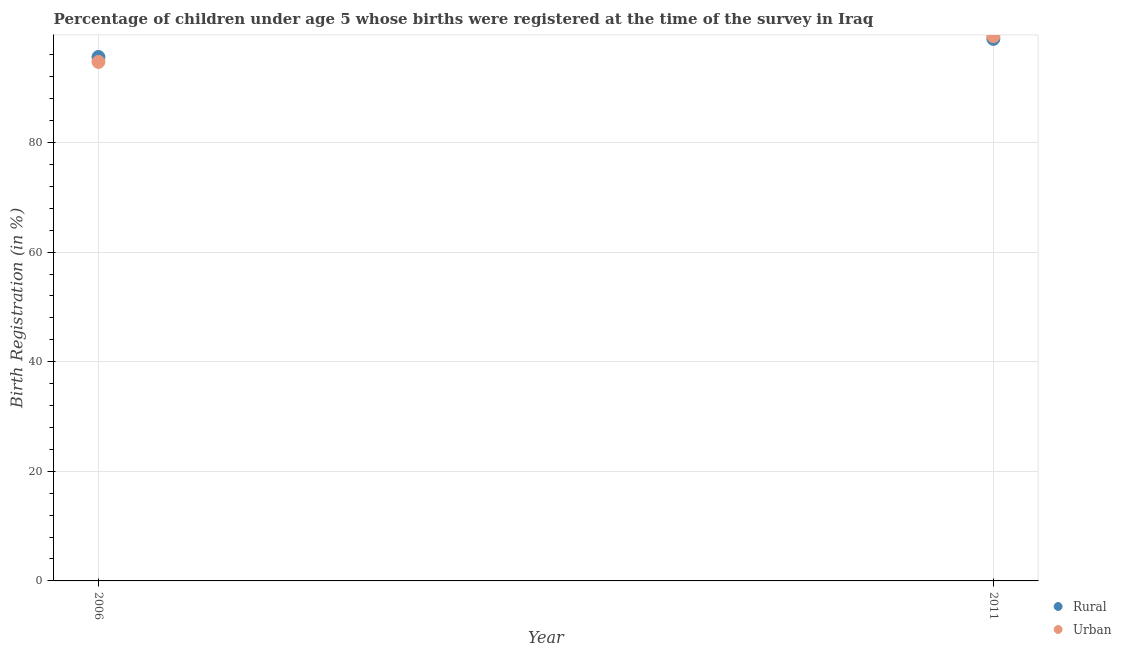Is the number of dotlines equal to the number of legend labels?
Keep it short and to the point. Yes. What is the rural birth registration in 2006?
Your answer should be very brief. 95.6. Across all years, what is the maximum urban birth registration?
Make the answer very short. 99.4. Across all years, what is the minimum rural birth registration?
Offer a very short reply. 95.6. What is the total rural birth registration in the graph?
Give a very brief answer. 194.5. What is the difference between the urban birth registration in 2006 and that in 2011?
Provide a succinct answer. -4.7. What is the difference between the urban birth registration in 2011 and the rural birth registration in 2006?
Your answer should be compact. 3.8. What is the average rural birth registration per year?
Provide a short and direct response. 97.25. In the year 2006, what is the difference between the urban birth registration and rural birth registration?
Your answer should be very brief. -0.9. What is the ratio of the urban birth registration in 2006 to that in 2011?
Give a very brief answer. 0.95. Is the rural birth registration in 2006 less than that in 2011?
Ensure brevity in your answer.  Yes. In how many years, is the rural birth registration greater than the average rural birth registration taken over all years?
Give a very brief answer. 1. How many years are there in the graph?
Your response must be concise. 2. Are the values on the major ticks of Y-axis written in scientific E-notation?
Offer a terse response. No. Does the graph contain any zero values?
Provide a short and direct response. No. Where does the legend appear in the graph?
Keep it short and to the point. Bottom right. How many legend labels are there?
Keep it short and to the point. 2. What is the title of the graph?
Keep it short and to the point. Percentage of children under age 5 whose births were registered at the time of the survey in Iraq. What is the label or title of the X-axis?
Offer a very short reply. Year. What is the label or title of the Y-axis?
Your response must be concise. Birth Registration (in %). What is the Birth Registration (in %) of Rural in 2006?
Your answer should be very brief. 95.6. What is the Birth Registration (in %) of Urban in 2006?
Ensure brevity in your answer.  94.7. What is the Birth Registration (in %) in Rural in 2011?
Provide a succinct answer. 98.9. What is the Birth Registration (in %) of Urban in 2011?
Ensure brevity in your answer.  99.4. Across all years, what is the maximum Birth Registration (in %) in Rural?
Ensure brevity in your answer.  98.9. Across all years, what is the maximum Birth Registration (in %) in Urban?
Offer a terse response. 99.4. Across all years, what is the minimum Birth Registration (in %) of Rural?
Offer a very short reply. 95.6. Across all years, what is the minimum Birth Registration (in %) in Urban?
Offer a very short reply. 94.7. What is the total Birth Registration (in %) of Rural in the graph?
Make the answer very short. 194.5. What is the total Birth Registration (in %) of Urban in the graph?
Keep it short and to the point. 194.1. What is the difference between the Birth Registration (in %) in Urban in 2006 and that in 2011?
Provide a short and direct response. -4.7. What is the average Birth Registration (in %) in Rural per year?
Your answer should be compact. 97.25. What is the average Birth Registration (in %) of Urban per year?
Ensure brevity in your answer.  97.05. In the year 2006, what is the difference between the Birth Registration (in %) of Rural and Birth Registration (in %) of Urban?
Offer a very short reply. 0.9. What is the ratio of the Birth Registration (in %) in Rural in 2006 to that in 2011?
Your response must be concise. 0.97. What is the ratio of the Birth Registration (in %) in Urban in 2006 to that in 2011?
Make the answer very short. 0.95. What is the difference between the highest and the second highest Birth Registration (in %) in Rural?
Your answer should be compact. 3.3. What is the difference between the highest and the lowest Birth Registration (in %) in Urban?
Make the answer very short. 4.7. 